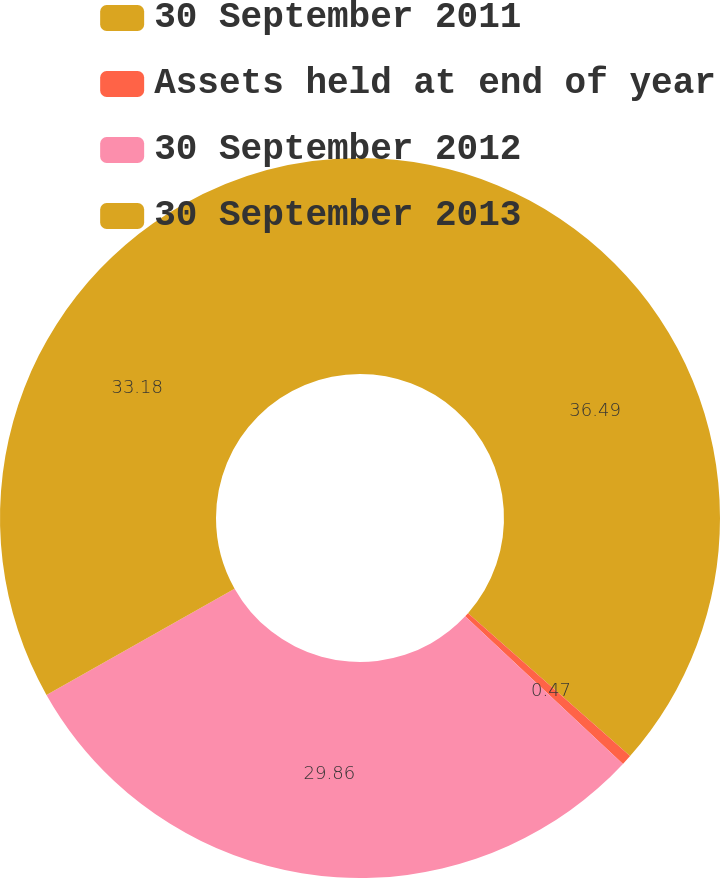Convert chart. <chart><loc_0><loc_0><loc_500><loc_500><pie_chart><fcel>30 September 2011<fcel>Assets held at end of year<fcel>30 September 2012<fcel>30 September 2013<nl><fcel>36.5%<fcel>0.47%<fcel>29.86%<fcel>33.18%<nl></chart> 